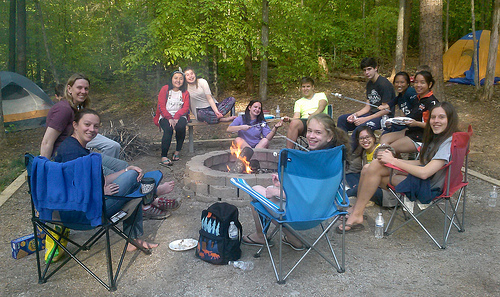<image>
Can you confirm if the bag is behind the chair? No. The bag is not behind the chair. From this viewpoint, the bag appears to be positioned elsewhere in the scene. Is the chair in front of the tent? Yes. The chair is positioned in front of the tent, appearing closer to the camera viewpoint. Is the fire in front of the log? No. The fire is not in front of the log. The spatial positioning shows a different relationship between these objects. 